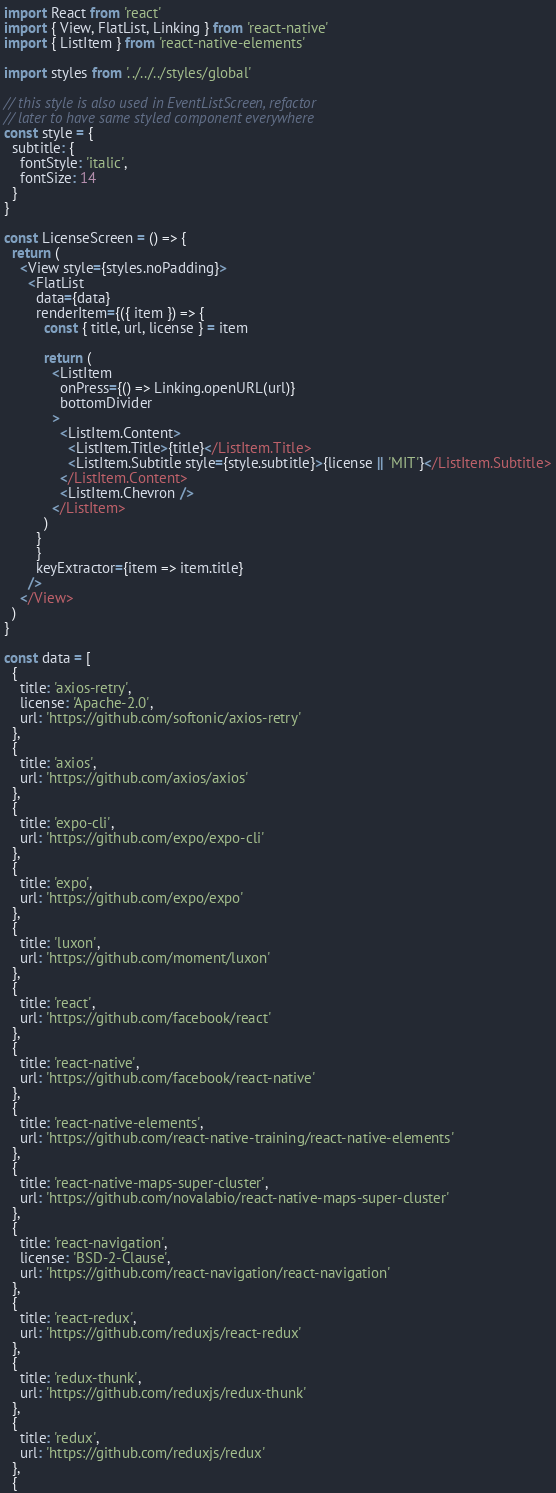Convert code to text. <code><loc_0><loc_0><loc_500><loc_500><_JavaScript_>import React from 'react'
import { View, FlatList, Linking } from 'react-native'
import { ListItem } from 'react-native-elements'

import styles from '../../../styles/global'

// this style is also used in EventListScreen, refactor
// later to have same styled component everywhere
const style = {
  subtitle: {
    fontStyle: 'italic',
    fontSize: 14
  }
}

const LicenseScreen = () => {
  return (
    <View style={styles.noPadding}>
      <FlatList
        data={data}
        renderItem={({ item }) => {
          const { title, url, license } = item

          return (
            <ListItem
              onPress={() => Linking.openURL(url)}
              bottomDivider
            >
              <ListItem.Content>
                <ListItem.Title>{title}</ListItem.Title>
                <ListItem.Subtitle style={style.subtitle}>{license || 'MIT'}</ListItem.Subtitle>
              </ListItem.Content>
              <ListItem.Chevron />
            </ListItem>
          )
        }
        }
        keyExtractor={item => item.title}
      />
    </View>
  )
}

const data = [
  {
    title: 'axios-retry',
    license: 'Apache-2.0',
    url: 'https://github.com/softonic/axios-retry'
  },
  {
    title: 'axios',
    url: 'https://github.com/axios/axios'
  },
  {
    title: 'expo-cli',
    url: 'https://github.com/expo/expo-cli'
  },
  {
    title: 'expo',
    url: 'https://github.com/expo/expo'
  },
  {
    title: 'luxon',
    url: 'https://github.com/moment/luxon'
  },
  {
    title: 'react',
    url: 'https://github.com/facebook/react'
  },
  {
    title: 'react-native',
    url: 'https://github.com/facebook/react-native'
  },
  {
    title: 'react-native-elements',
    url: 'https://github.com/react-native-training/react-native-elements'
  },
  {
    title: 'react-native-maps-super-cluster',
    url: 'https://github.com/novalabio/react-native-maps-super-cluster'
  },
  {
    title: 'react-navigation',
    license: 'BSD-2-Clause',
    url: 'https://github.com/react-navigation/react-navigation'
  },
  {
    title: 'react-redux',
    url: 'https://github.com/reduxjs/react-redux'
  },
  {
    title: 'redux-thunk',
    url: 'https://github.com/reduxjs/redux-thunk'
  },
  {
    title: 'redux',
    url: 'https://github.com/reduxjs/redux'
  },
  {</code> 